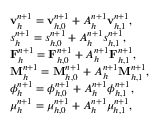<formula> <loc_0><loc_0><loc_500><loc_500>\begin{array} { r l } & { v _ { h } ^ { n + 1 } = v _ { h , 0 } ^ { n + 1 } + A _ { h } ^ { n + 1 } v _ { h , 1 } ^ { n + 1 } , } \\ & { s _ { h } ^ { n + 1 } = s _ { h , 0 } ^ { n + 1 } + A _ { h } ^ { n + 1 } s _ { h , 1 } ^ { n + 1 } , } \\ & { F _ { h } ^ { n + 1 } = F _ { h , 0 } ^ { n + 1 } + A _ { h } ^ { n + 1 } F _ { h , 1 } ^ { n + 1 } , } \\ & { M _ { h } ^ { n + 1 } = M _ { h , 0 } ^ { n + 1 } + A _ { h } ^ { n + 1 } M _ { h , 1 } ^ { n + 1 } , } \\ & { \phi _ { h } ^ { n + 1 } = \phi _ { h , 0 } ^ { n + 1 } + A _ { h } ^ { n + 1 } \phi _ { h , 1 } ^ { n + 1 } , } \\ & { \mu _ { h } ^ { n + 1 } = \mu _ { h , 0 } ^ { n + 1 } + A _ { h } ^ { n + 1 } \mu _ { h , 1 } ^ { n + 1 } , } \end{array}</formula> 